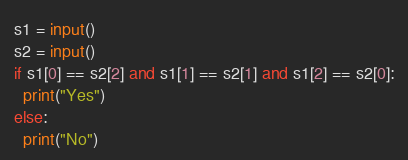<code> <loc_0><loc_0><loc_500><loc_500><_Python_>s1 = input()
s2 = input()
if s1[0] == s2[2] and s1[1] == s2[1] and s1[2] == s2[0]:
  print("Yes")
else:
  print("No")</code> 